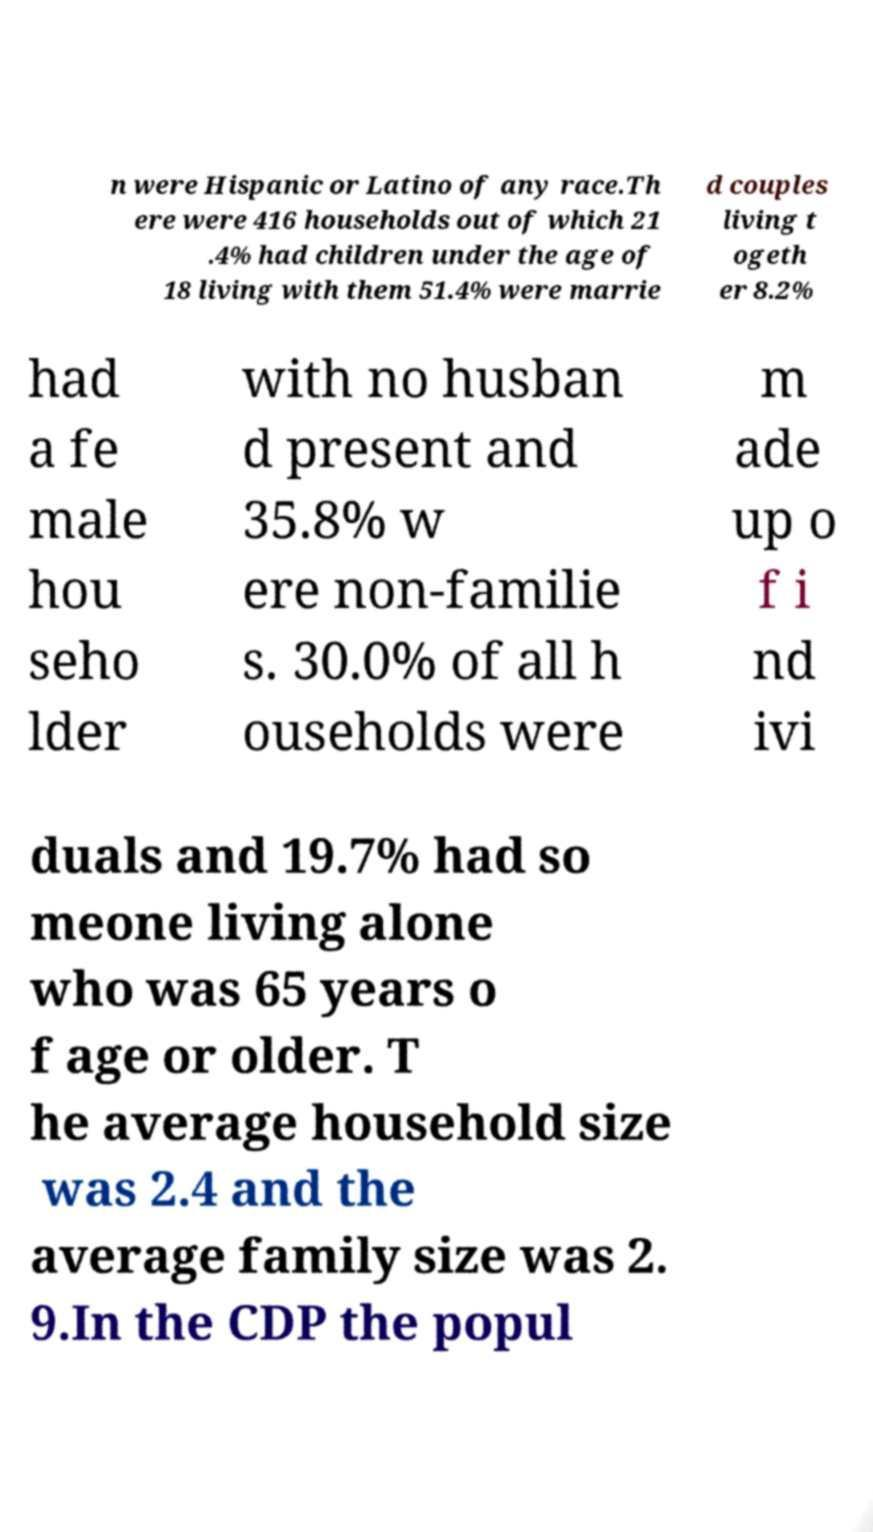Could you extract and type out the text from this image? n were Hispanic or Latino of any race.Th ere were 416 households out of which 21 .4% had children under the age of 18 living with them 51.4% were marrie d couples living t ogeth er 8.2% had a fe male hou seho lder with no husban d present and 35.8% w ere non-familie s. 30.0% of all h ouseholds were m ade up o f i nd ivi duals and 19.7% had so meone living alone who was 65 years o f age or older. T he average household size was 2.4 and the average family size was 2. 9.In the CDP the popul 